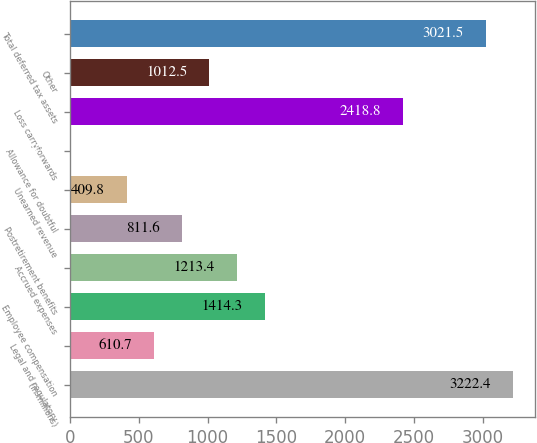Convert chart. <chart><loc_0><loc_0><loc_500><loc_500><bar_chart><fcel>(in millions)<fcel>Legal and regulatory<fcel>Employee compensation<fcel>Accrued expenses<fcel>Postretirement benefits<fcel>Unearned revenue<fcel>Allowance for doubtful<fcel>Loss carryforwards<fcel>Other<fcel>Total deferred tax assets<nl><fcel>3222.4<fcel>610.7<fcel>1414.3<fcel>1213.4<fcel>811.6<fcel>409.8<fcel>8<fcel>2418.8<fcel>1012.5<fcel>3021.5<nl></chart> 